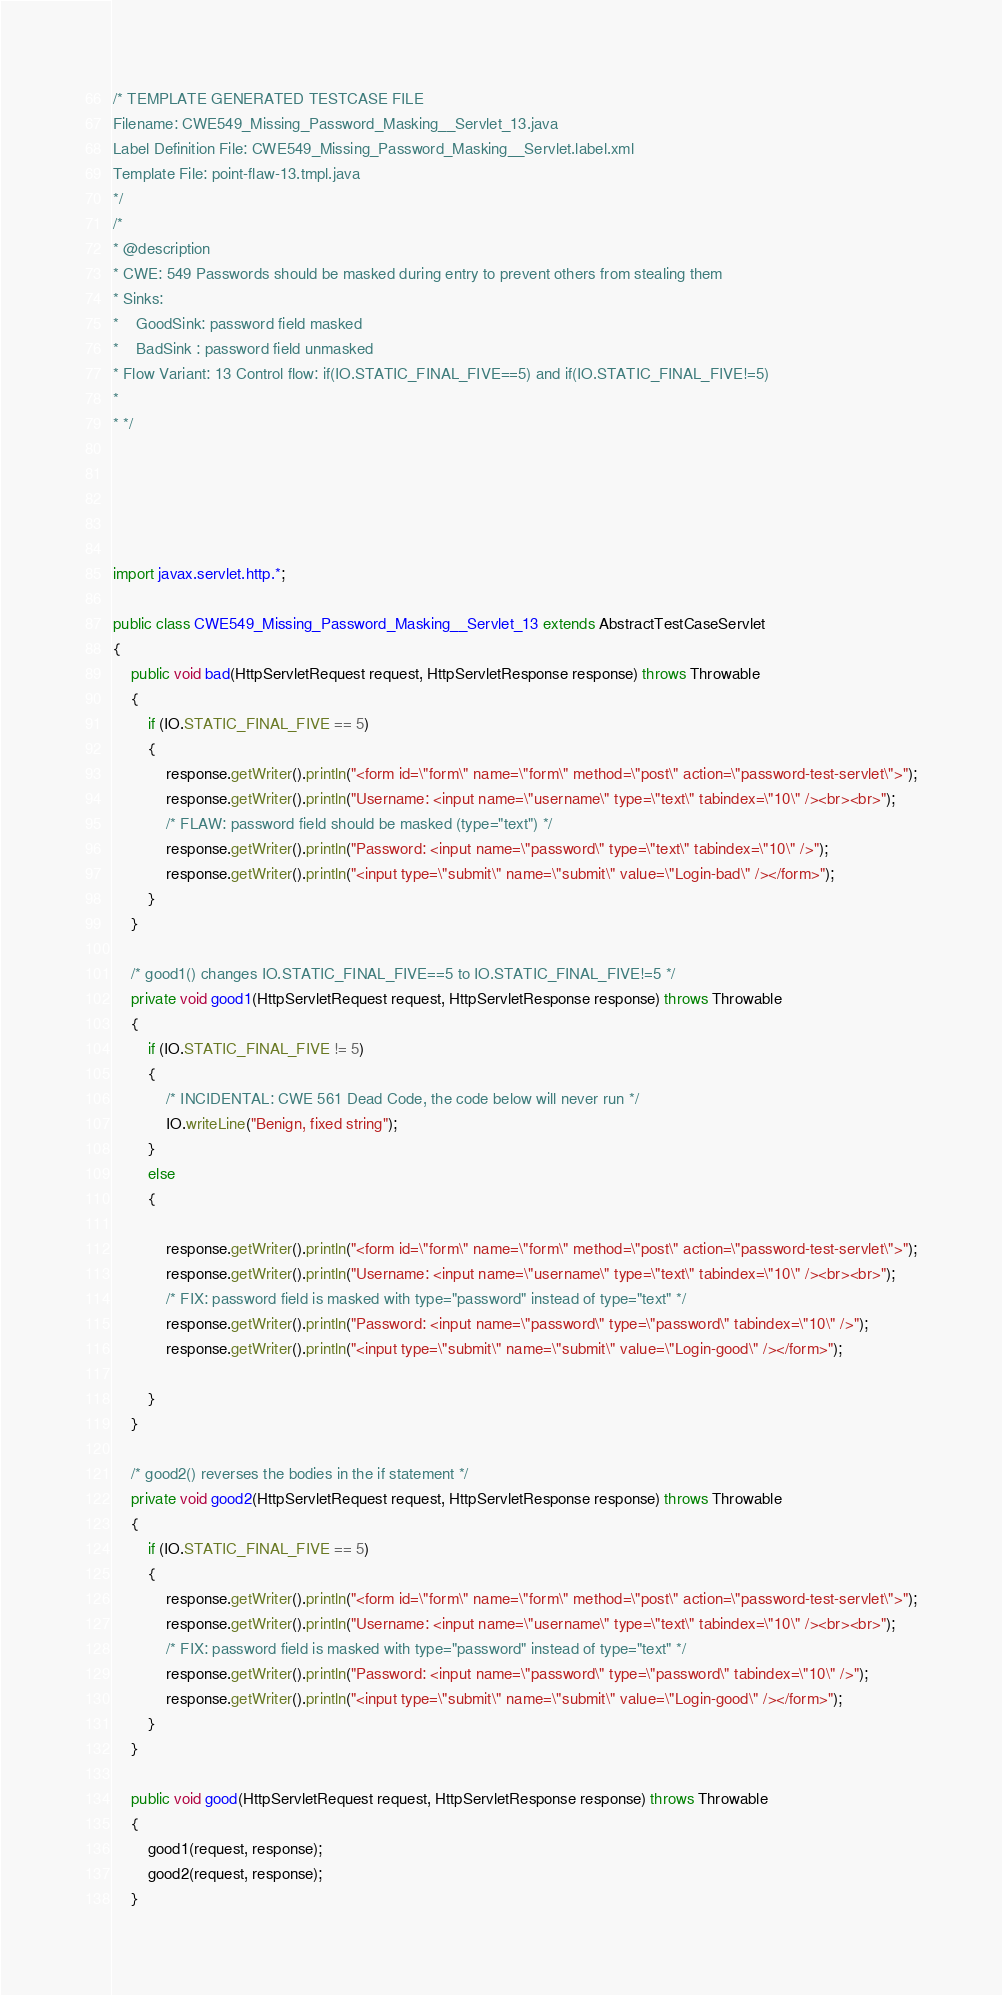<code> <loc_0><loc_0><loc_500><loc_500><_Java_>/* TEMPLATE GENERATED TESTCASE FILE
Filename: CWE549_Missing_Password_Masking__Servlet_13.java
Label Definition File: CWE549_Missing_Password_Masking__Servlet.label.xml
Template File: point-flaw-13.tmpl.java
*/
/*
* @description
* CWE: 549 Passwords should be masked during entry to prevent others from stealing them
* Sinks:
*    GoodSink: password field masked
*    BadSink : password field unmasked
* Flow Variant: 13 Control flow: if(IO.STATIC_FINAL_FIVE==5) and if(IO.STATIC_FINAL_FIVE!=5)
*
* */





import javax.servlet.http.*;

public class CWE549_Missing_Password_Masking__Servlet_13 extends AbstractTestCaseServlet
{
    public void bad(HttpServletRequest request, HttpServletResponse response) throws Throwable
    {
        if (IO.STATIC_FINAL_FIVE == 5)
        {
            response.getWriter().println("<form id=\"form\" name=\"form\" method=\"post\" action=\"password-test-servlet\">");
            response.getWriter().println("Username: <input name=\"username\" type=\"text\" tabindex=\"10\" /><br><br>");
            /* FLAW: password field should be masked (type="text") */
            response.getWriter().println("Password: <input name=\"password\" type=\"text\" tabindex=\"10\" />");
            response.getWriter().println("<input type=\"submit\" name=\"submit\" value=\"Login-bad\" /></form>");
        }
    }

    /* good1() changes IO.STATIC_FINAL_FIVE==5 to IO.STATIC_FINAL_FIVE!=5 */
    private void good1(HttpServletRequest request, HttpServletResponse response) throws Throwable
    {
        if (IO.STATIC_FINAL_FIVE != 5)
        {
            /* INCIDENTAL: CWE 561 Dead Code, the code below will never run */
            IO.writeLine("Benign, fixed string");
        }
        else
        {

            response.getWriter().println("<form id=\"form\" name=\"form\" method=\"post\" action=\"password-test-servlet\">");
            response.getWriter().println("Username: <input name=\"username\" type=\"text\" tabindex=\"10\" /><br><br>");
            /* FIX: password field is masked with type="password" instead of type="text" */
            response.getWriter().println("Password: <input name=\"password\" type=\"password\" tabindex=\"10\" />");
            response.getWriter().println("<input type=\"submit\" name=\"submit\" value=\"Login-good\" /></form>");

        }
    }

    /* good2() reverses the bodies in the if statement */
    private void good2(HttpServletRequest request, HttpServletResponse response) throws Throwable
    {
        if (IO.STATIC_FINAL_FIVE == 5)
        {
            response.getWriter().println("<form id=\"form\" name=\"form\" method=\"post\" action=\"password-test-servlet\">");
            response.getWriter().println("Username: <input name=\"username\" type=\"text\" tabindex=\"10\" /><br><br>");
            /* FIX: password field is masked with type="password" instead of type="text" */
            response.getWriter().println("Password: <input name=\"password\" type=\"password\" tabindex=\"10\" />");
            response.getWriter().println("<input type=\"submit\" name=\"submit\" value=\"Login-good\" /></form>");
        }
    }

    public void good(HttpServletRequest request, HttpServletResponse response) throws Throwable
    {
        good1(request, response);
        good2(request, response);
    }
</code> 